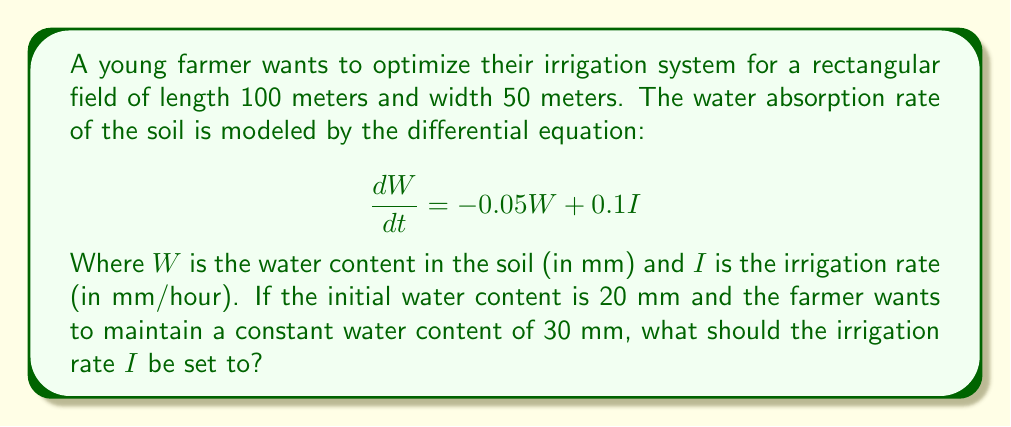Can you answer this question? To solve this problem, we'll follow these steps:

1) We want to find the steady-state solution where the water content remains constant at 30 mm. This means $\frac{dW}{dt} = 0$.

2) Substituting these values into the differential equation:

   $$0 = -0.05W + 0.1I$$
   $$0 = -0.05(30) + 0.1I$$

3) Solve for $I$:

   $$0.1I = 0.05(30)$$
   $$0.1I = 1.5$$
   $$I = 15$$

4) To verify, we can check if this irrigation rate maintains the water content at 30 mm:

   $$\frac{dW}{dt} = -0.05(30) + 0.1(15) = -1.5 + 1.5 = 0$$

   This confirms that the water content will remain constant at 30 mm with this irrigation rate.

5) The irrigation rate $I$ should be set to 15 mm/hour to maintain the desired water content.
Answer: 15 mm/hour 